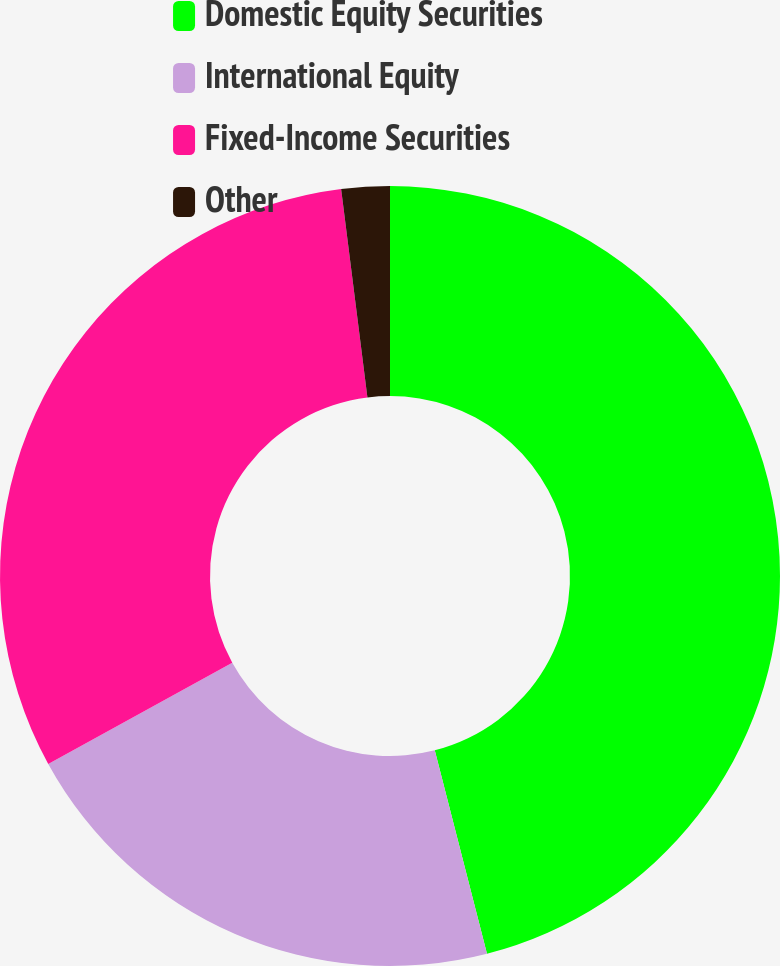Convert chart to OTSL. <chart><loc_0><loc_0><loc_500><loc_500><pie_chart><fcel>Domestic Equity Securities<fcel>International Equity<fcel>Fixed-Income Securities<fcel>Other<nl><fcel>46.0%<fcel>21.0%<fcel>31.0%<fcel>2.0%<nl></chart> 